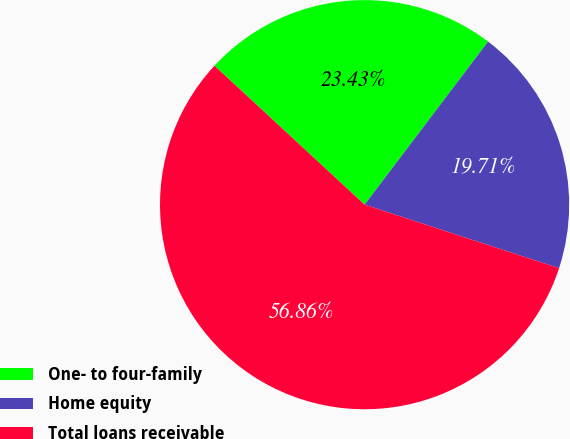Convert chart to OTSL. <chart><loc_0><loc_0><loc_500><loc_500><pie_chart><fcel>One- to four-family<fcel>Home equity<fcel>Total loans receivable<nl><fcel>23.43%<fcel>19.71%<fcel>56.86%<nl></chart> 